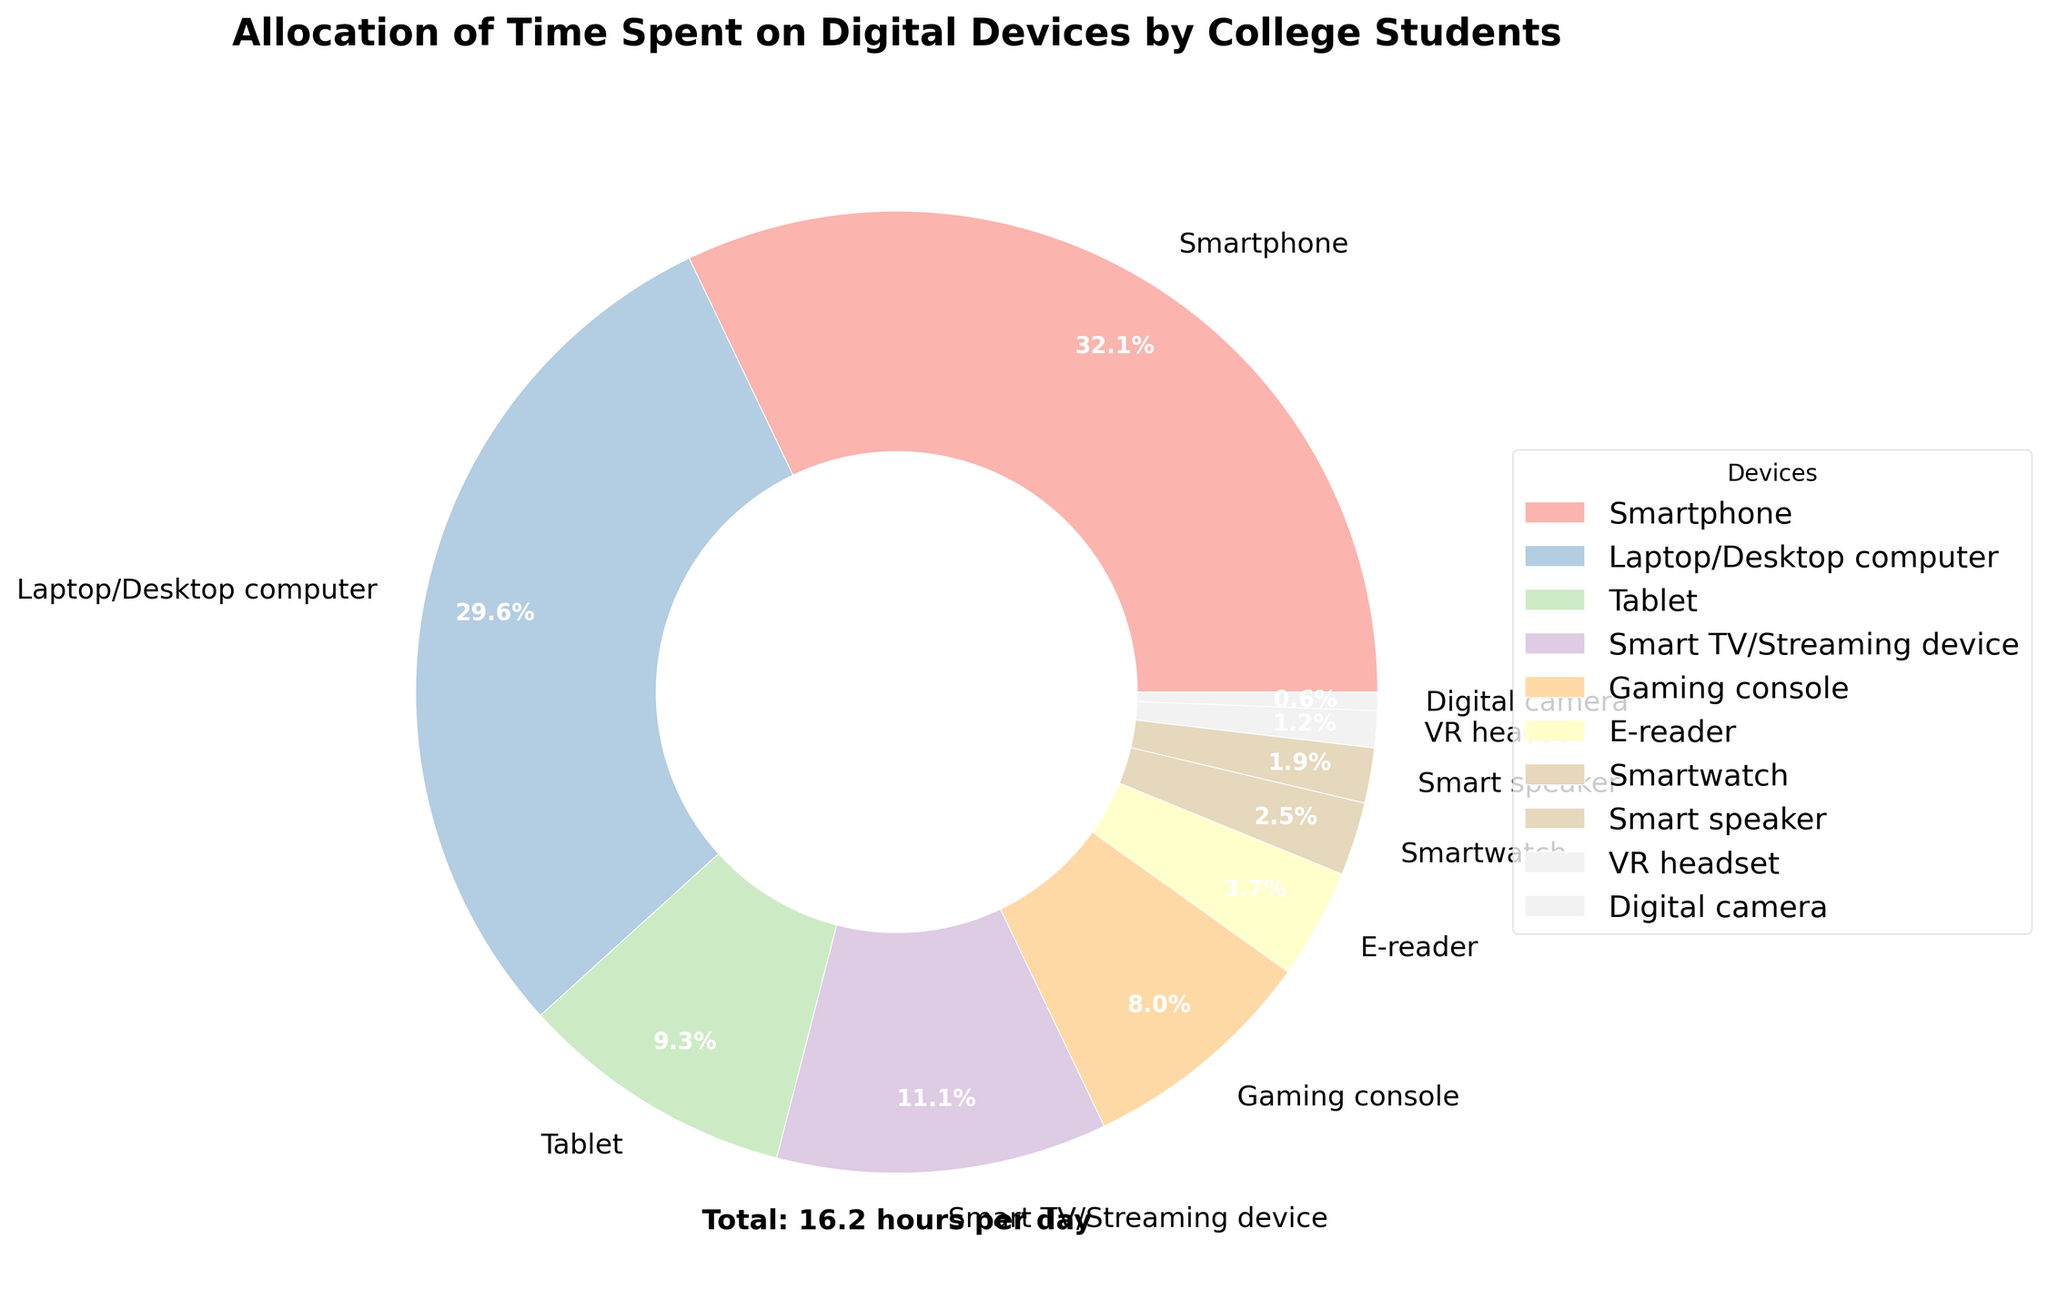What percentage of total time do students spend on smartphones and laptops/desktops combined? Add the hours spent on smartphones and laptops/desktops: 5.2 + 4.8 = 10. Divide 10 by the total hours per day spent on all devices (15.2 hours), and then multiply by 100 to convert to a percentage: (10 / 15.2) * 100 ≈ 65.8%
Answer: ~65.8% Which device has the least amount of time spent on it? Identify the device with the smallest number of hours per day from the data. The VR headset has 0.2 hours, which is the least.
Answer: VR headset How much more time is spent on smart TVs/streaming devices compared to gaming consoles? Subtract the time spent on gaming consoles from the time spent on smart TVs/streaming devices: 1.8 - 1.3 = 0.5 hours.
Answer: 0.5 hours What are the three least-used devices and their total time spent? Identify the three devices with the lowest hours per day: Digital camera (0.1), Smart speaker (0.3), and Smartwatch (0.4). Sum their hours: 0.1 + 0.3 + 0.4 = 0.8 hours.
Answer: Digital camera, Smart speaker, Smartwatch; 0.8 hours How does the time spent on tablets compare to e-readers? Compare the hours spent on tablets (1.5) and e-readers (0.6). Tablets have more hours. 1.5 is greater than 0.6.
Answer: Tablets (1.5 hours) > E-readers (0.6 hours) What is the total time spent on all devices? Sum up all the hours per day: 5.2 + 4.8 + 1.5 + 1.8 + 1.3 + 0.6 + 0.4 + 0.3 + 0.2 + 0.1 = 16.2 hours.
Answer: 16.2 hours Which device category represents around 30% of the total usage time? Since smartphones take up 32.1% of the total time (5.2 hours out of 16.2), they represent around 30% of the total usage time.
Answer: Smartphone What is the average time spent on devices other than smartphones and laptops/desktops? Sum the hours of all devices except smartphones and laptops/desktops: 1.5 (Tablet) + 1.8 (Smart TV/Streaming) + 1.3 (Gaming console) + 0.6 (E-reader) + 0.4 (Smartwatch) + 0.3 (Smart speaker) + 0.2 (VR headset) + 0.1 (Digital camera) = 6.2. Divide by the number of other devices (8): 6.2 / 8 = 0.775 hours.
Answer: 0.775 hours Analyze the dominating color in the pie chart – what device does it represent? Identify the largest section by visually inspecting the pie chart. The largest section corresponds to the smartphone, typically represented by the most significant color segment.
Answer: Smartphone 